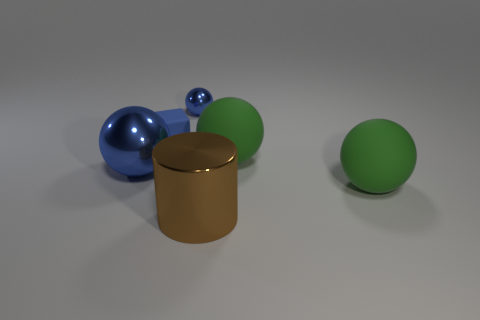Subtract all green spheres. How many were subtracted if there are1green spheres left? 1 Subtract all yellow cylinders. Subtract all yellow balls. How many cylinders are left? 1 Add 1 blue objects. How many objects exist? 7 Subtract all blocks. How many objects are left? 5 Add 5 red rubber objects. How many red rubber objects exist? 5 Subtract 0 gray cylinders. How many objects are left? 6 Subtract all cylinders. Subtract all big cyan rubber cylinders. How many objects are left? 5 Add 3 large green matte objects. How many large green matte objects are left? 5 